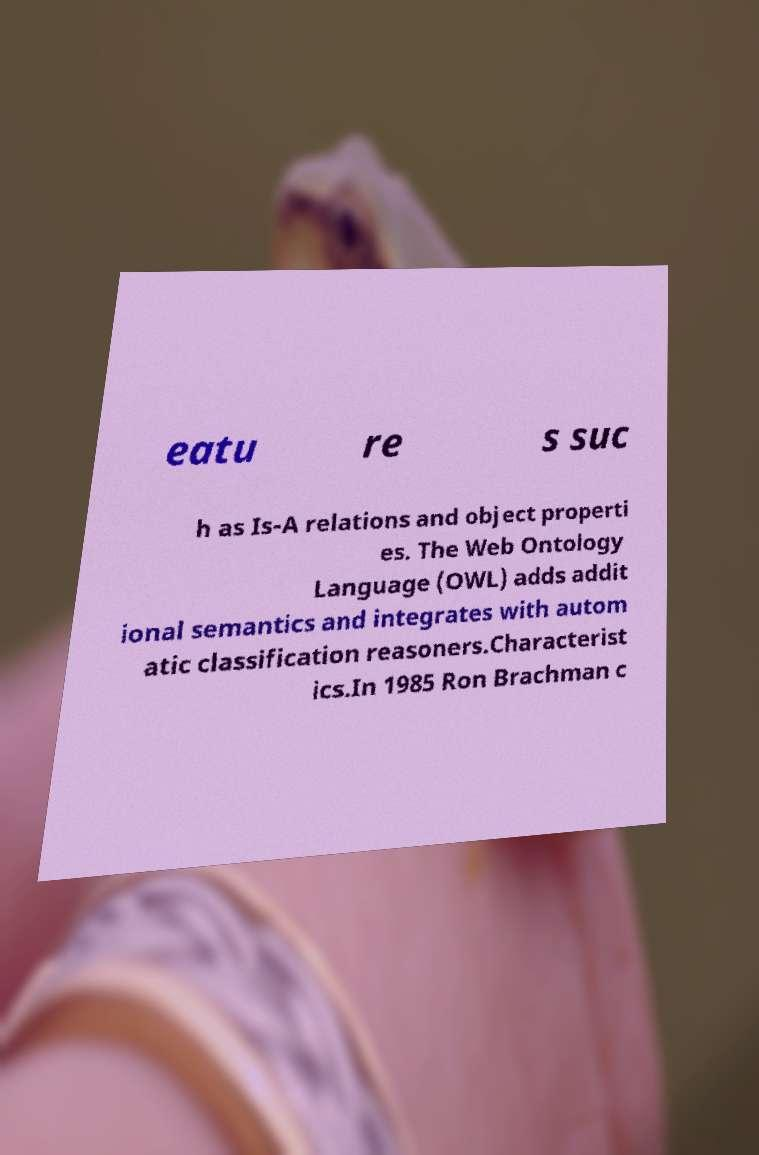What messages or text are displayed in this image? I need them in a readable, typed format. eatu re s suc h as Is-A relations and object properti es. The Web Ontology Language (OWL) adds addit ional semantics and integrates with autom atic classification reasoners.Characterist ics.In 1985 Ron Brachman c 